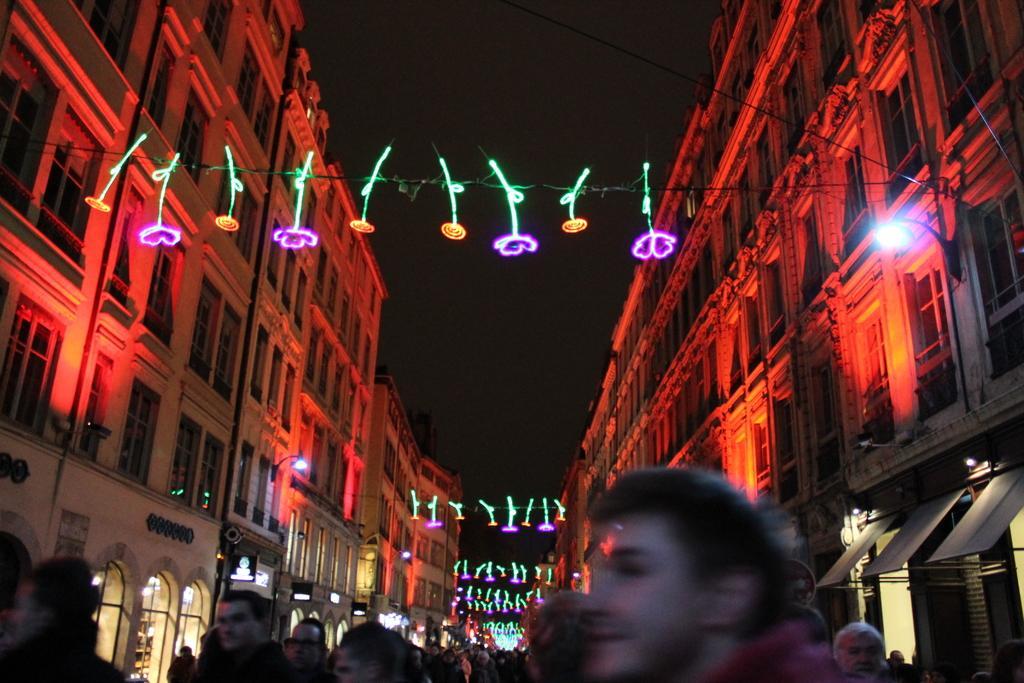In one or two sentences, can you explain what this image depicts? In this picture we can see the buildings, poles, windows, lights, wires. At the bottom of the image we can see a group of people, boarded, doors. At the top of the image we can see the sky. 